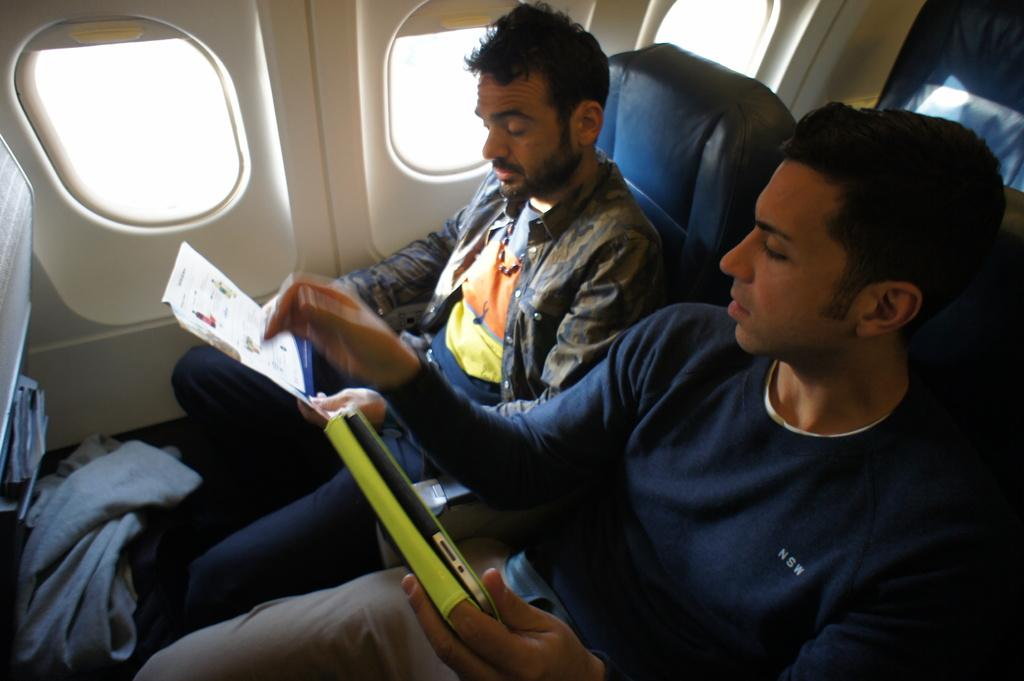What type of location is depicted in the image? The image is an inside view of an aeroplane. How many people are visible in the image? There are two men sitting on the seats. What is one of the men holding in his hand? One man is holding a device in his hand. What is the other man doing in the image? The other man is holding a book and looking into it. What type of hen can be seen walking around the aeroplane in the image? There is no hen present in the image; it is an inside view of an aeroplane with two men. What is the dinner menu for the passengers in the image? The image does not show any dinner menu or information about the passengers' meals. 